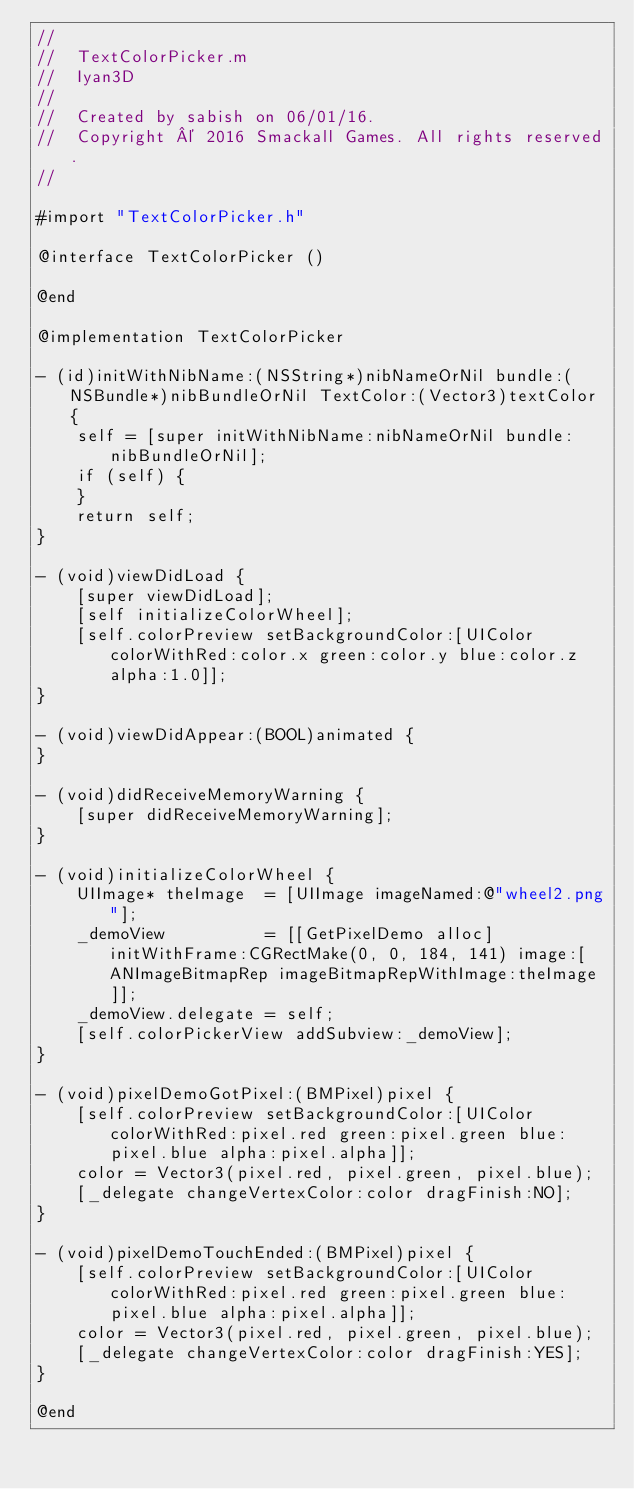Convert code to text. <code><loc_0><loc_0><loc_500><loc_500><_ObjectiveC_>//
//  TextColorPicker.m
//  Iyan3D
//
//  Created by sabish on 06/01/16.
//  Copyright © 2016 Smackall Games. All rights reserved.
//

#import "TextColorPicker.h"

@interface TextColorPicker ()

@end

@implementation TextColorPicker

- (id)initWithNibName:(NSString*)nibNameOrNil bundle:(NSBundle*)nibBundleOrNil TextColor:(Vector3)textColor {
    self = [super initWithNibName:nibNameOrNil bundle:nibBundleOrNil];
    if (self) {
    }
    return self;
}

- (void)viewDidLoad {
    [super viewDidLoad];
    [self initializeColorWheel];
    [self.colorPreview setBackgroundColor:[UIColor colorWithRed:color.x green:color.y blue:color.z alpha:1.0]];
}

- (void)viewDidAppear:(BOOL)animated {
}

- (void)didReceiveMemoryWarning {
    [super didReceiveMemoryWarning];
}

- (void)initializeColorWheel {
    UIImage* theImage  = [UIImage imageNamed:@"wheel2.png"];
    _demoView          = [[GetPixelDemo alloc] initWithFrame:CGRectMake(0, 0, 184, 141) image:[ANImageBitmapRep imageBitmapRepWithImage:theImage]];
    _demoView.delegate = self;
    [self.colorPickerView addSubview:_demoView];
}

- (void)pixelDemoGotPixel:(BMPixel)pixel {
    [self.colorPreview setBackgroundColor:[UIColor colorWithRed:pixel.red green:pixel.green blue:pixel.blue alpha:pixel.alpha]];
    color = Vector3(pixel.red, pixel.green, pixel.blue);
    [_delegate changeVertexColor:color dragFinish:NO];
}

- (void)pixelDemoTouchEnded:(BMPixel)pixel {
    [self.colorPreview setBackgroundColor:[UIColor colorWithRed:pixel.red green:pixel.green blue:pixel.blue alpha:pixel.alpha]];
    color = Vector3(pixel.red, pixel.green, pixel.blue);
    [_delegate changeVertexColor:color dragFinish:YES];
}

@end
</code> 